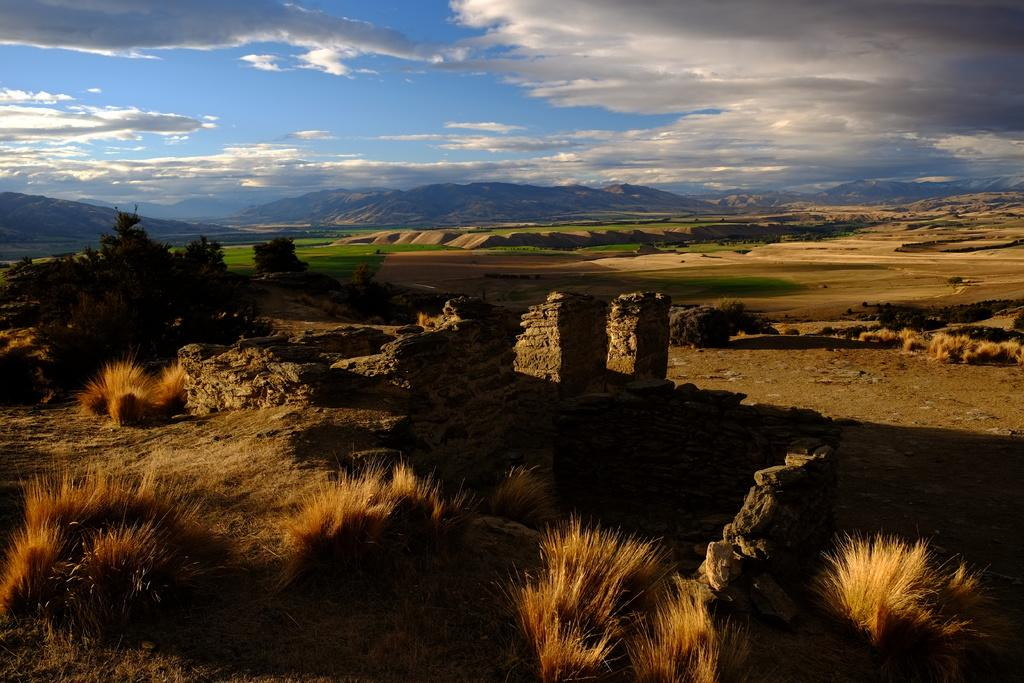What type of surface can be seen in the image? The ground is visible in the image. What type of vegetation is present in the image? There is grass and plants in the image. What geographical features can be seen in the image? There are hills in the image. What type of structures are present in the image? There are walls in the image. What is visible in the background of the image? The sky is visible in the image, and clouds are present in the sky. What type of gun is hanging on the hook in the image? There is no gun or hook present in the image. What is the title of the image? The image does not have a title, as it is a visual representation and not a written work. 